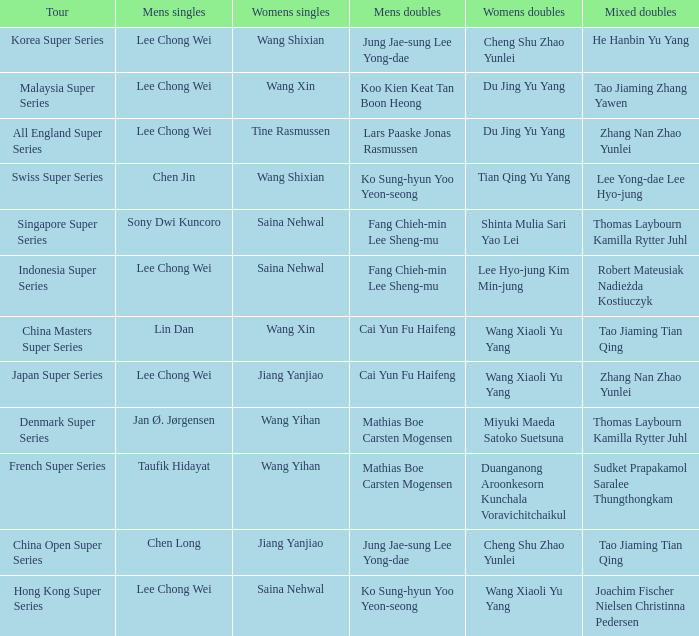Who are the female doubles participants in the tour french super series? Duanganong Aroonkesorn Kunchala Voravichitchaikul. 